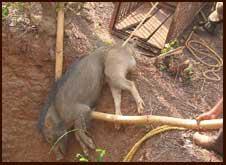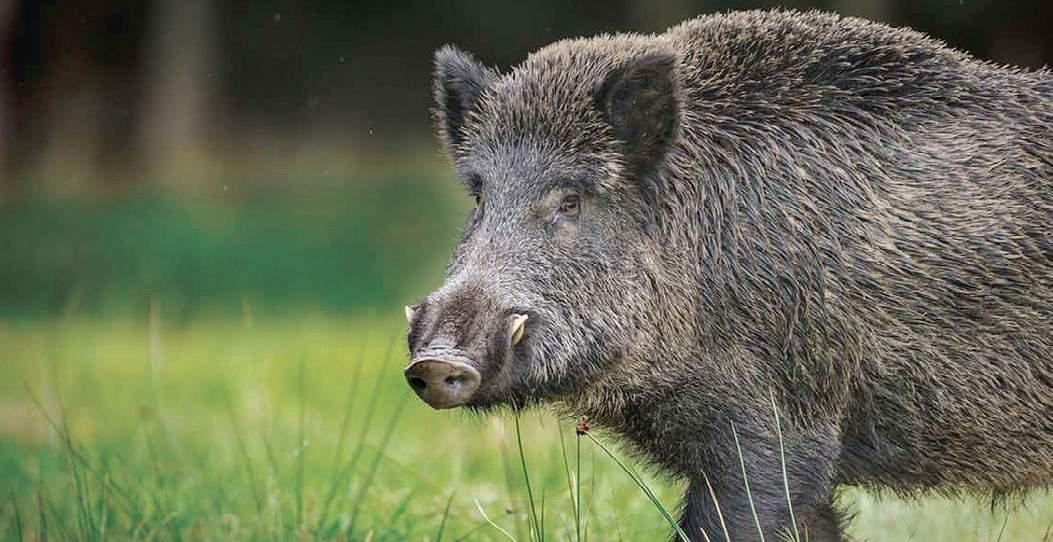The first image is the image on the left, the second image is the image on the right. Considering the images on both sides, is "The boar in the right image is standing in green foliage." valid? Answer yes or no. Yes. The first image is the image on the left, the second image is the image on the right. For the images shown, is this caption "Both animals are standing in a field." true? Answer yes or no. No. 